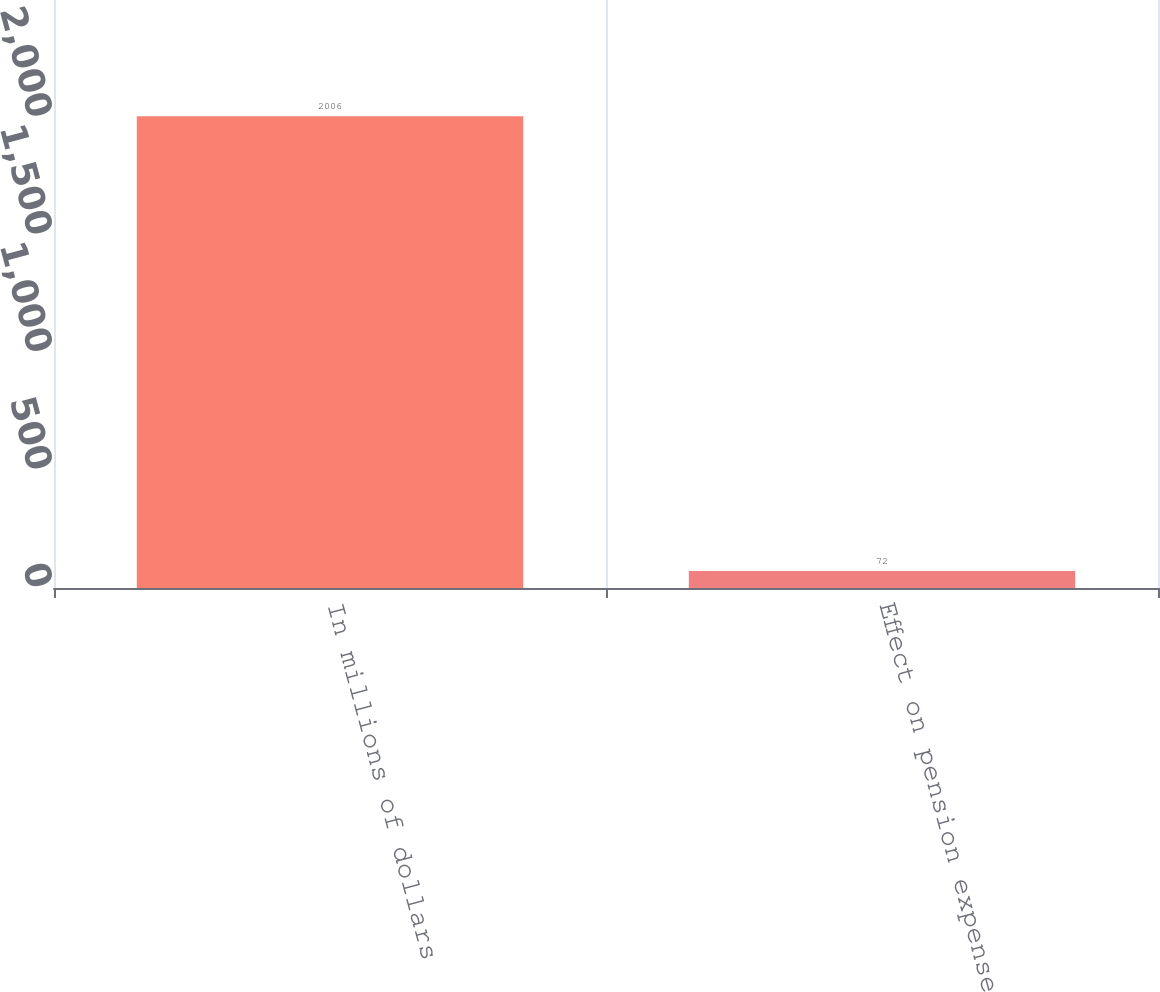Convert chart. <chart><loc_0><loc_0><loc_500><loc_500><bar_chart><fcel>In millions of dollars<fcel>Effect on pension expense for<nl><fcel>2006<fcel>72<nl></chart> 